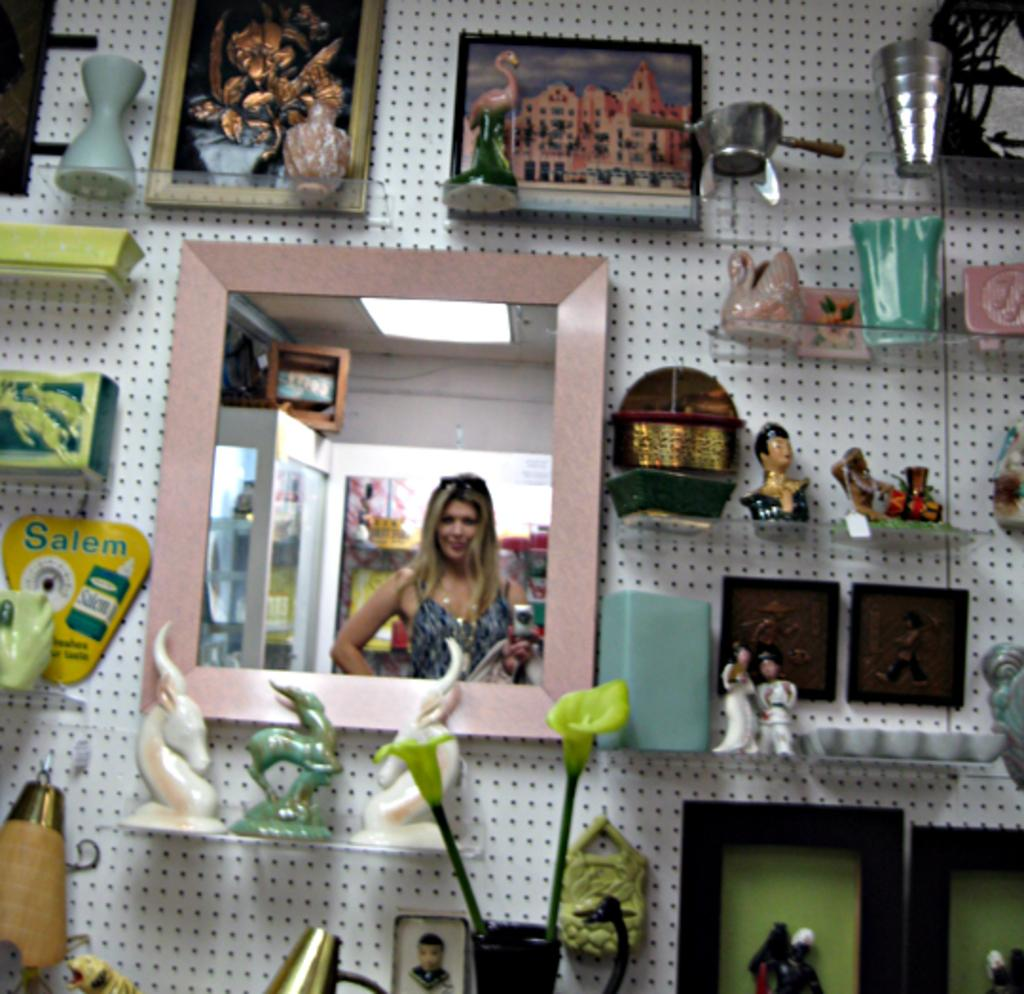What is the main feature of the wall in the image? The wall has small holes in the image. What is attached to the wall? There is a mirror and sculptures on the wall. What type of storage is available on the wall? There are glass racks on the wall. What else can be seen on the wall in the image? There are things placed on the wall. How many cars are parked on the wall in the image? There are no cars present in the image; it features a wall with small holes, a mirror, sculptures, glass racks, and other things. Can you see a rake hanging on the wall in the image? There is no rake visible in the image. 